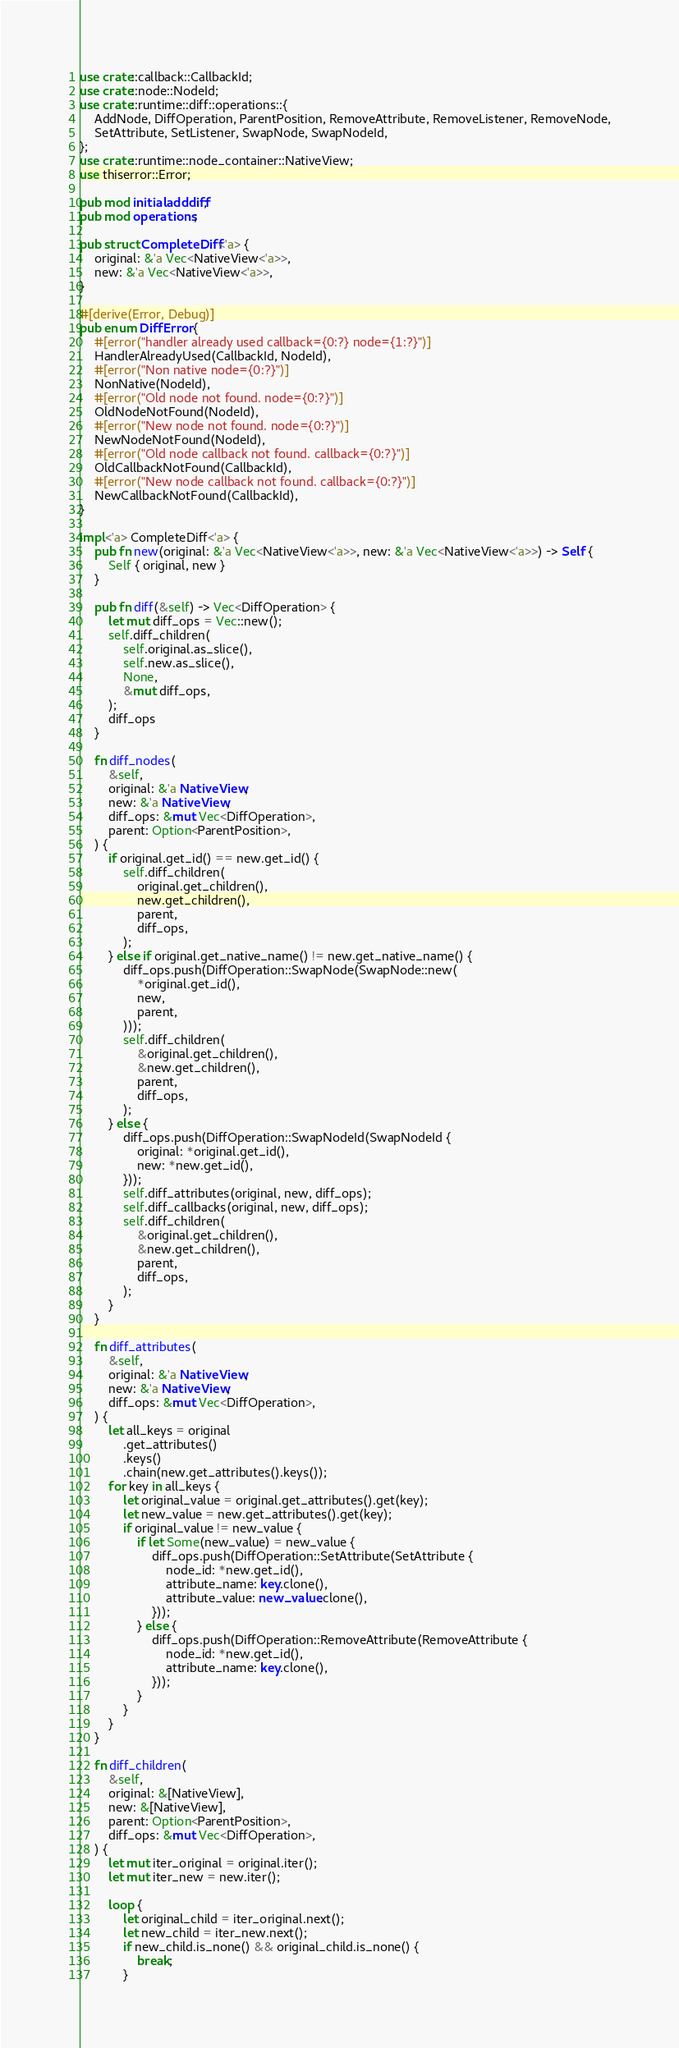Convert code to text. <code><loc_0><loc_0><loc_500><loc_500><_Rust_>use crate::callback::CallbackId;
use crate::node::NodeId;
use crate::runtime::diff::operations::{
    AddNode, DiffOperation, ParentPosition, RemoveAttribute, RemoveListener, RemoveNode,
    SetAttribute, SetListener, SwapNode, SwapNodeId,
};
use crate::runtime::node_container::NativeView;
use thiserror::Error;

pub mod initialadddiff;
pub mod operations;

pub struct CompleteDiff<'a> {
    original: &'a Vec<NativeView<'a>>,
    new: &'a Vec<NativeView<'a>>,
}

#[derive(Error, Debug)]
pub enum DiffError {
    #[error("handler already used callback={0:?} node={1:?}")]
    HandlerAlreadyUsed(CallbackId, NodeId),
    #[error("Non native node={0:?}")]
    NonNative(NodeId),
    #[error("Old node not found. node={0:?}")]
    OldNodeNotFound(NodeId),
    #[error("New node not found. node={0:?}")]
    NewNodeNotFound(NodeId),
    #[error("Old node callback not found. callback={0:?}")]
    OldCallbackNotFound(CallbackId),
    #[error("New node callback not found. callback={0:?}")]
    NewCallbackNotFound(CallbackId),
}

impl<'a> CompleteDiff<'a> {
    pub fn new(original: &'a Vec<NativeView<'a>>, new: &'a Vec<NativeView<'a>>) -> Self {
        Self { original, new }
    }

    pub fn diff(&self) -> Vec<DiffOperation> {
        let mut diff_ops = Vec::new();
        self.diff_children(
            self.original.as_slice(),
            self.new.as_slice(),
            None,
            &mut diff_ops,
        );
        diff_ops
    }

    fn diff_nodes(
        &self,
        original: &'a NativeView,
        new: &'a NativeView,
        diff_ops: &mut Vec<DiffOperation>,
        parent: Option<ParentPosition>,
    ) {
        if original.get_id() == new.get_id() {
            self.diff_children(
                original.get_children(),
                new.get_children(),
                parent,
                diff_ops,
            );
        } else if original.get_native_name() != new.get_native_name() {
            diff_ops.push(DiffOperation::SwapNode(SwapNode::new(
                *original.get_id(),
                new,
                parent,
            )));
            self.diff_children(
                &original.get_children(),
                &new.get_children(),
                parent,
                diff_ops,
            );
        } else {
            diff_ops.push(DiffOperation::SwapNodeId(SwapNodeId {
                original: *original.get_id(),
                new: *new.get_id(),
            }));
            self.diff_attributes(original, new, diff_ops);
            self.diff_callbacks(original, new, diff_ops);
            self.diff_children(
                &original.get_children(),
                &new.get_children(),
                parent,
                diff_ops,
            );
        }
    }

    fn diff_attributes(
        &self,
        original: &'a NativeView,
        new: &'a NativeView,
        diff_ops: &mut Vec<DiffOperation>,
    ) {
        let all_keys = original
            .get_attributes()
            .keys()
            .chain(new.get_attributes().keys());
        for key in all_keys {
            let original_value = original.get_attributes().get(key);
            let new_value = new.get_attributes().get(key);
            if original_value != new_value {
                if let Some(new_value) = new_value {
                    diff_ops.push(DiffOperation::SetAttribute(SetAttribute {
                        node_id: *new.get_id(),
                        attribute_name: key.clone(),
                        attribute_value: new_value.clone(),
                    }));
                } else {
                    diff_ops.push(DiffOperation::RemoveAttribute(RemoveAttribute {
                        node_id: *new.get_id(),
                        attribute_name: key.clone(),
                    }));
                }
            }
        }
    }

    fn diff_children(
        &self,
        original: &[NativeView],
        new: &[NativeView],
        parent: Option<ParentPosition>,
        diff_ops: &mut Vec<DiffOperation>,
    ) {
        let mut iter_original = original.iter();
        let mut iter_new = new.iter();

        loop {
            let original_child = iter_original.next();
            let new_child = iter_new.next();
            if new_child.is_none() && original_child.is_none() {
                break;
            }</code> 